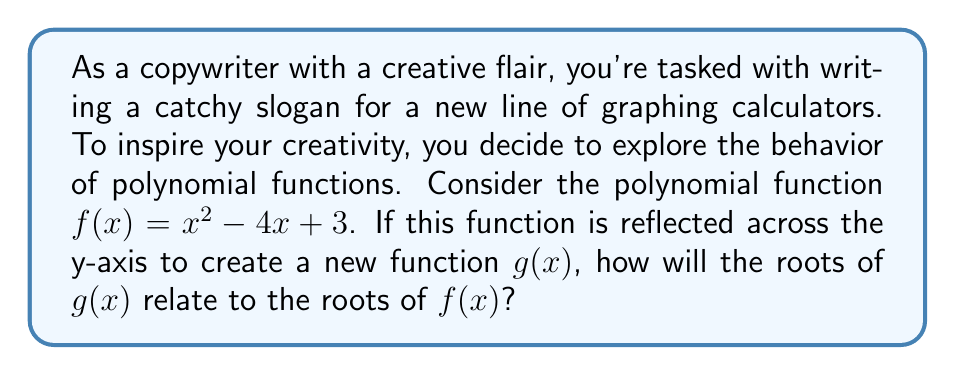Solve this math problem. Let's approach this step-by-step:

1) First, let's find the roots of $f(x) = x^2 - 4x + 3$:
   
   Using the quadratic formula, $x = \frac{-b \pm \sqrt{b^2 - 4ac}}{2a}$
   
   $x = \frac{4 \pm \sqrt{16 - 12}}{2} = \frac{4 \pm 2}{2}$
   
   So, the roots of $f(x)$ are $x = 1$ and $x = 3$

2) Now, to reflect $f(x)$ across the y-axis, we replace every $x$ with $-x$:
   
   $g(x) = (-x)^2 - 4(-x) + 3 = x^2 + 4x + 3$

3) To find the roots of $g(x)$, we use the quadratic formula again:
   
   $x = \frac{-4 \pm \sqrt{16 - 12}}{2} = \frac{-4 \pm 2}{2}$
   
   The roots of $g(x)$ are $x = -3$ and $x = -1$

4) Comparing the roots:
   $f(x)$ roots: 1 and 3
   $g(x)$ roots: -1 and -3

5) We can see that the roots of $g(x)$ are the negatives of the roots of $f(x)$.

This is true in general: when a polynomial function is reflected across the y-axis, its roots are negated (multiplied by -1).
Answer: The roots of $g(x)$ are the negatives of the roots of $f(x)$. 